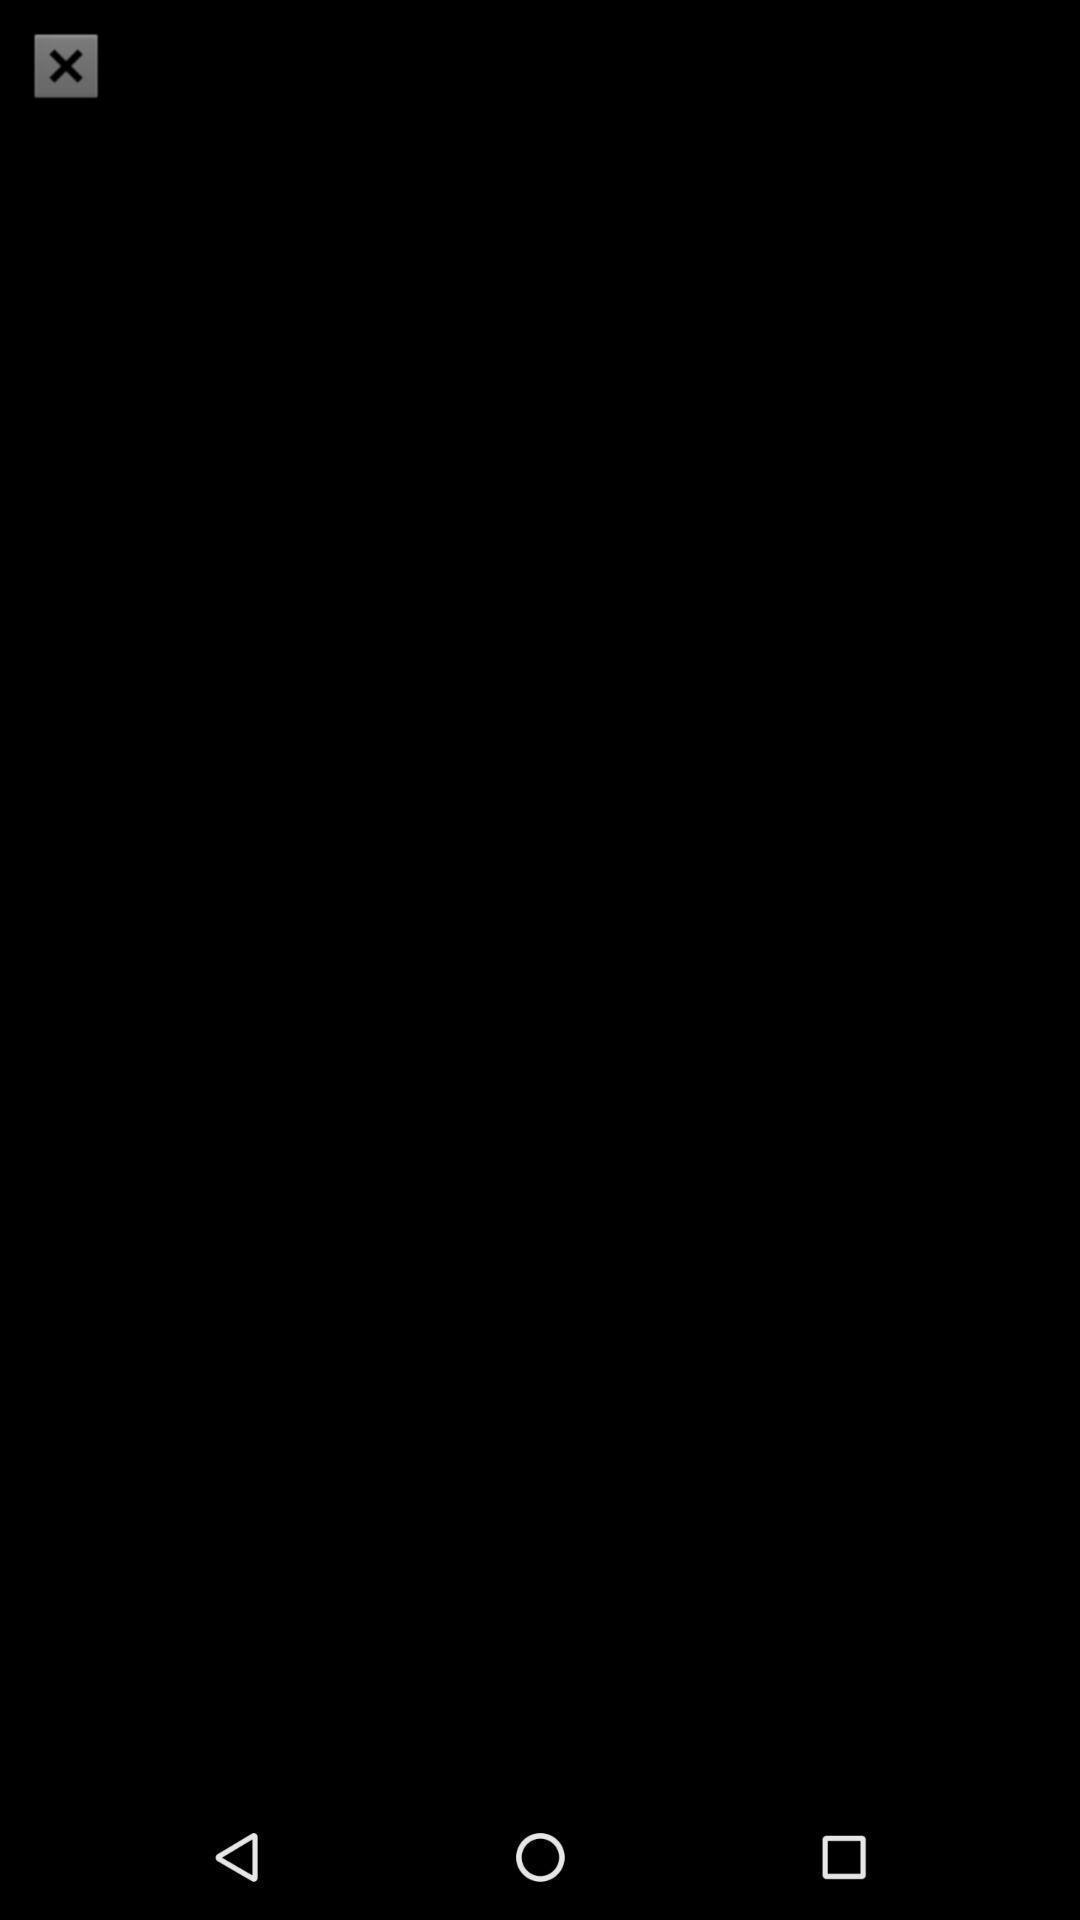Give me a summary of this screen capture. Page displaying a cancel icon. 